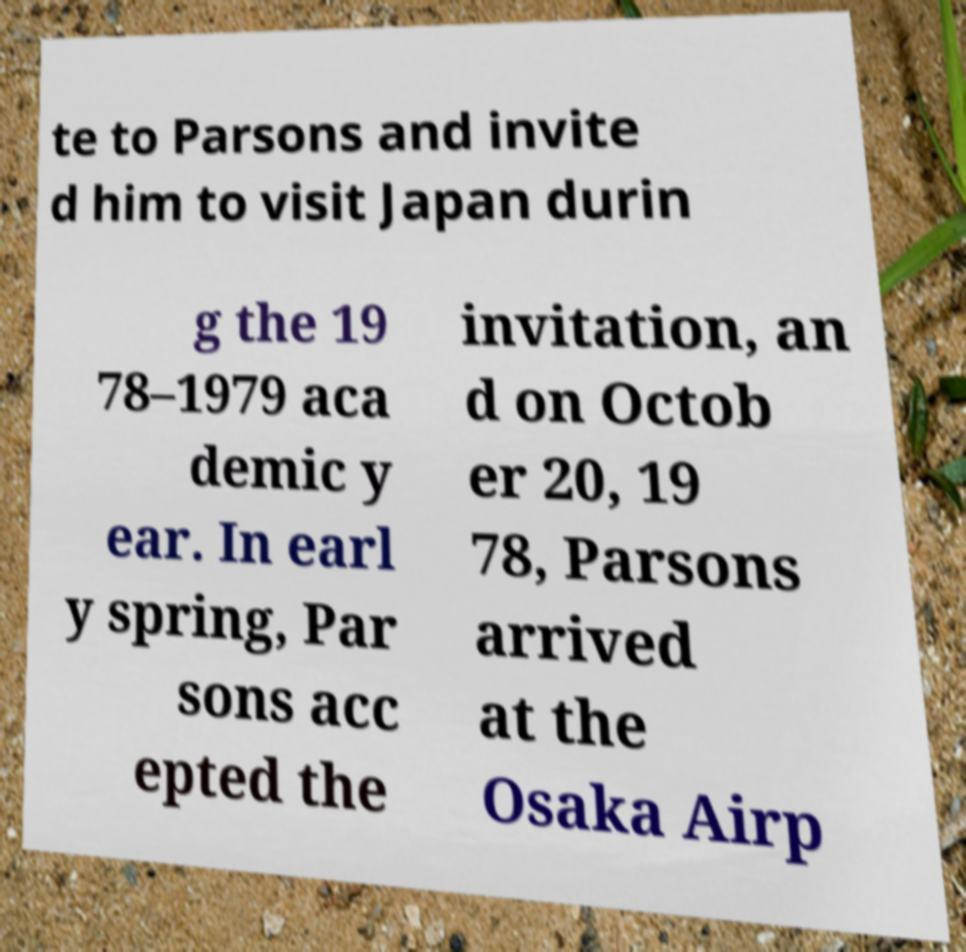What messages or text are displayed in this image? I need them in a readable, typed format. te to Parsons and invite d him to visit Japan durin g the 19 78–1979 aca demic y ear. In earl y spring, Par sons acc epted the invitation, an d on Octob er 20, 19 78, Parsons arrived at the Osaka Airp 